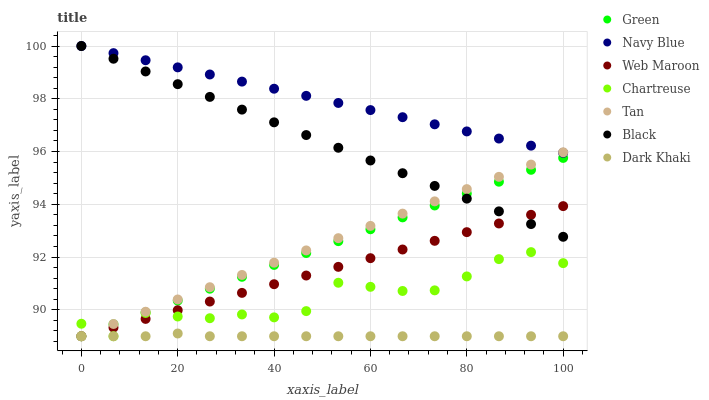Does Dark Khaki have the minimum area under the curve?
Answer yes or no. Yes. Does Navy Blue have the maximum area under the curve?
Answer yes or no. Yes. Does Web Maroon have the minimum area under the curve?
Answer yes or no. No. Does Web Maroon have the maximum area under the curve?
Answer yes or no. No. Is Navy Blue the smoothest?
Answer yes or no. Yes. Is Chartreuse the roughest?
Answer yes or no. Yes. Is Web Maroon the smoothest?
Answer yes or no. No. Is Web Maroon the roughest?
Answer yes or no. No. Does Web Maroon have the lowest value?
Answer yes or no. Yes. Does Black have the lowest value?
Answer yes or no. No. Does Black have the highest value?
Answer yes or no. Yes. Does Web Maroon have the highest value?
Answer yes or no. No. Is Dark Khaki less than Navy Blue?
Answer yes or no. Yes. Is Navy Blue greater than Dark Khaki?
Answer yes or no. Yes. Does Dark Khaki intersect Green?
Answer yes or no. Yes. Is Dark Khaki less than Green?
Answer yes or no. No. Is Dark Khaki greater than Green?
Answer yes or no. No. Does Dark Khaki intersect Navy Blue?
Answer yes or no. No. 